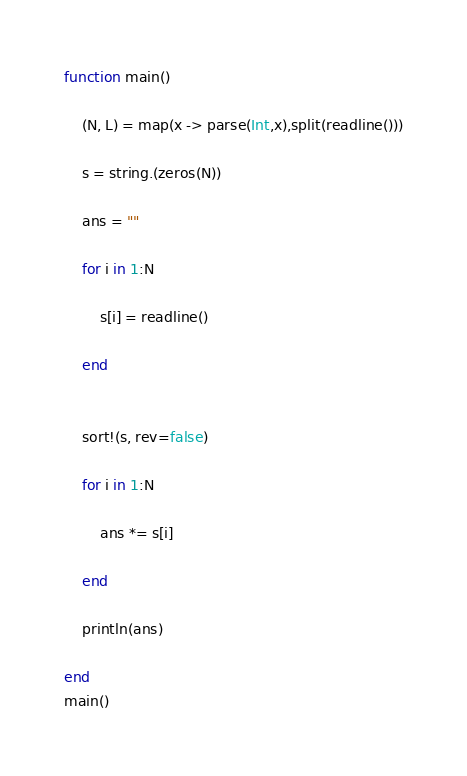Convert code to text. <code><loc_0><loc_0><loc_500><loc_500><_Julia_>function main()
    
    (N, L) = map(x -> parse(Int,x),split(readline()))
    
    s = string.(zeros(N))
    
    ans = "" 
    
    for i in 1:N
        
        s[i] = readline()

    end
 
    
    sort!(s, rev=false)
    
    for i in 1:N
        
        ans *= s[i]
        
    end
    
    println(ans)
    
end
main()</code> 